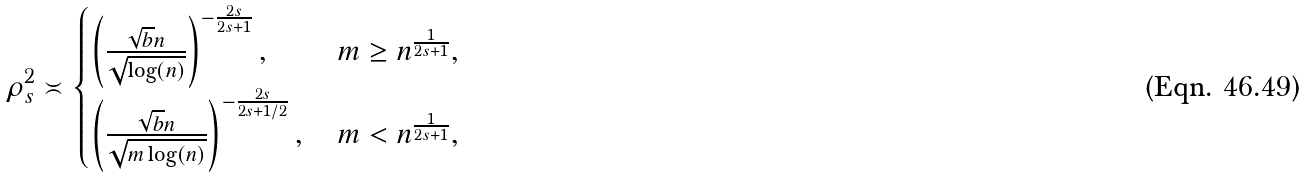<formula> <loc_0><loc_0><loc_500><loc_500>\rho ^ { 2 } _ { s } \asymp \begin{cases} \left ( \frac { \sqrt { b } n } { \sqrt { \log ( n ) } } \right ) ^ { - \frac { 2 s } { 2 s + 1 } } , & \, m \geq n ^ { \frac { 1 } { 2 s + 1 } } , \\ \left ( \frac { \sqrt { b } n } { \sqrt { m \log ( n ) } } \right ) ^ { - \frac { 2 s } { 2 s + 1 / 2 } } , & \, m < n ^ { \frac { 1 } { 2 s + 1 } } , \end{cases}</formula> 